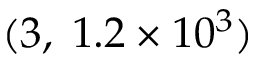<formula> <loc_0><loc_0><loc_500><loc_500>( 3 , \, 1 . 2 \times 1 0 ^ { 3 } )</formula> 